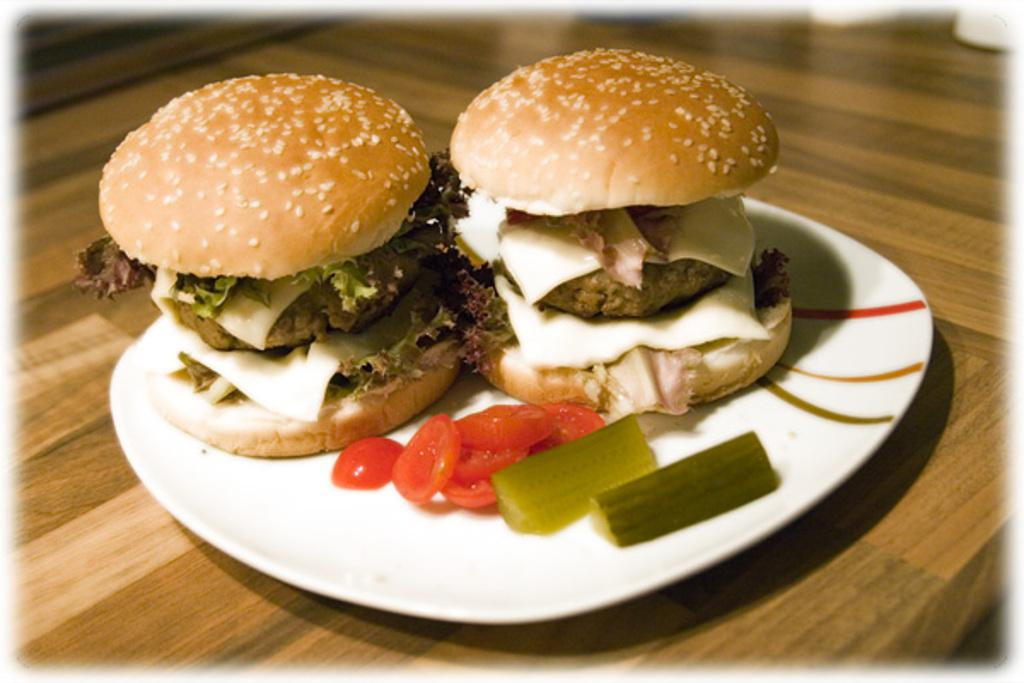What is on the plate that is visible in the image? The plate contains two burgers and a few slices of tomato. Where is the plate located in the image? The plate is placed on a table. What type of food is featured on the plate? The plate contains burgers and tomato slices. What type of book is placed on the plate in the image? There is no book present on the plate in the image; it contains two burgers and a few slices of tomato. 